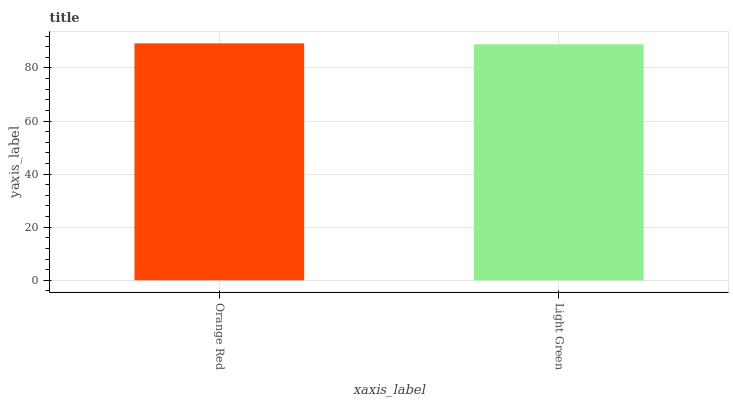Is Light Green the minimum?
Answer yes or no. Yes. Is Orange Red the maximum?
Answer yes or no. Yes. Is Light Green the maximum?
Answer yes or no. No. Is Orange Red greater than Light Green?
Answer yes or no. Yes. Is Light Green less than Orange Red?
Answer yes or no. Yes. Is Light Green greater than Orange Red?
Answer yes or no. No. Is Orange Red less than Light Green?
Answer yes or no. No. Is Orange Red the high median?
Answer yes or no. Yes. Is Light Green the low median?
Answer yes or no. Yes. Is Light Green the high median?
Answer yes or no. No. Is Orange Red the low median?
Answer yes or no. No. 